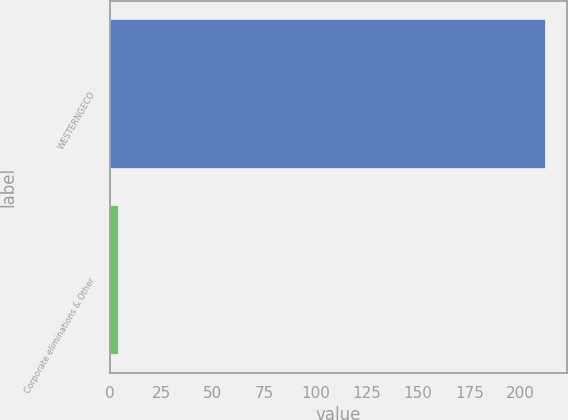Convert chart. <chart><loc_0><loc_0><loc_500><loc_500><bar_chart><fcel>WESTERNGECO<fcel>Corporate eliminations & Other<nl><fcel>212<fcel>4<nl></chart> 